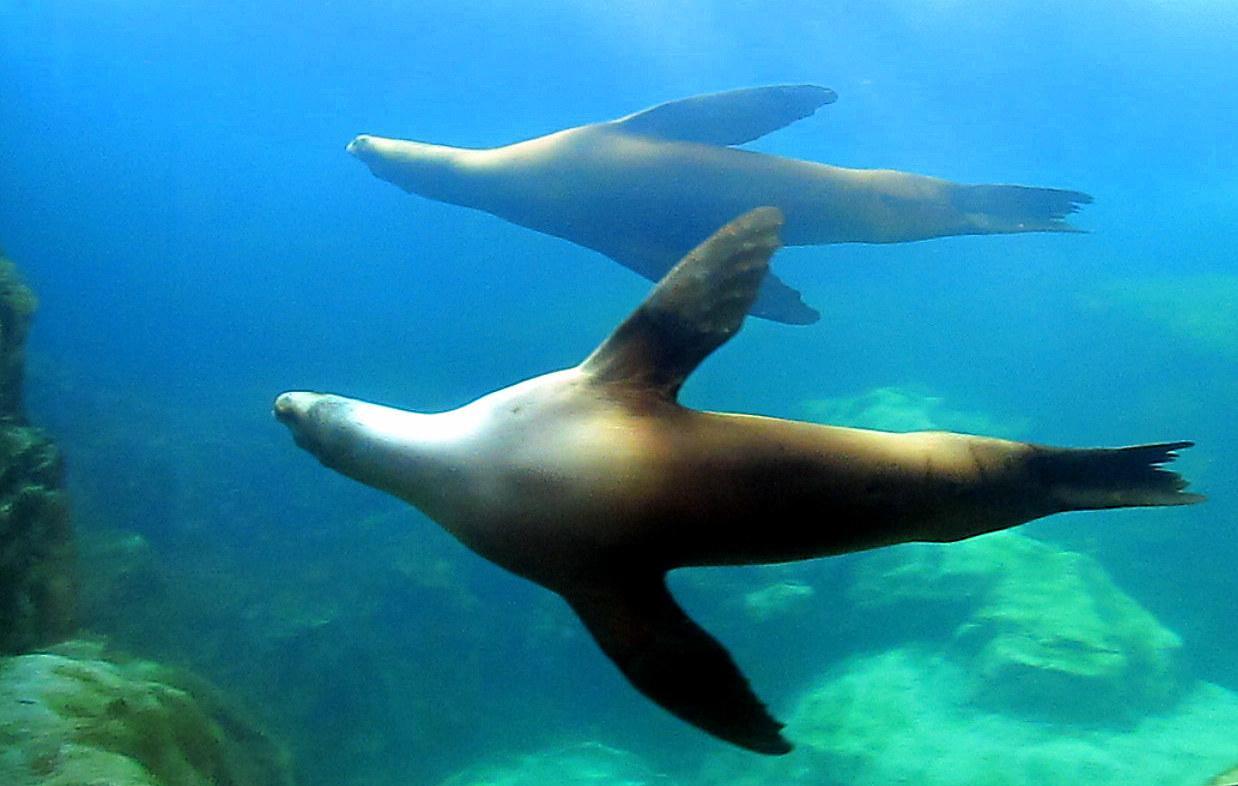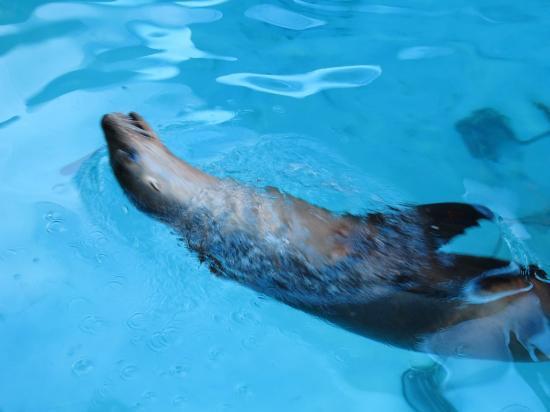The first image is the image on the left, the second image is the image on the right. Analyze the images presented: Is the assertion "there is a diver looking at a seal underwater" valid? Answer yes or no. No. The first image is the image on the left, the second image is the image on the right. Given the left and right images, does the statement "There is one person on the ocean floor." hold true? Answer yes or no. No. 